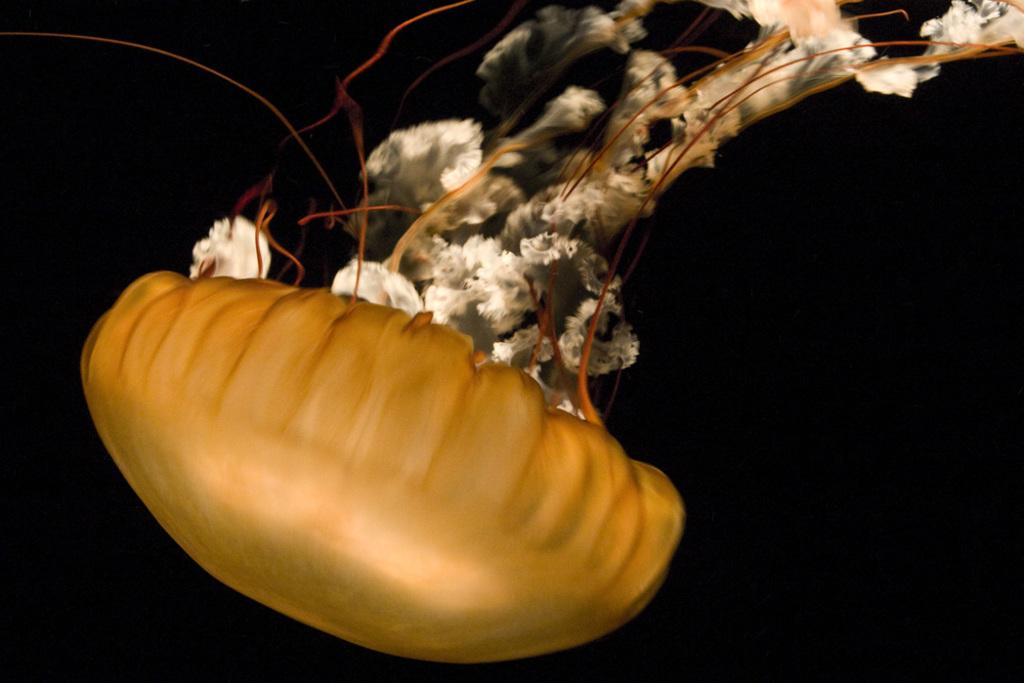What is the main subject in the foreground of the image? There is a jellyfish in the foreground of the image. What color is the background of the image? The background of the image is black. What hobbies do the mice in the image enjoy? There are no mice present in the image, so it is not possible to determine their hobbies. 